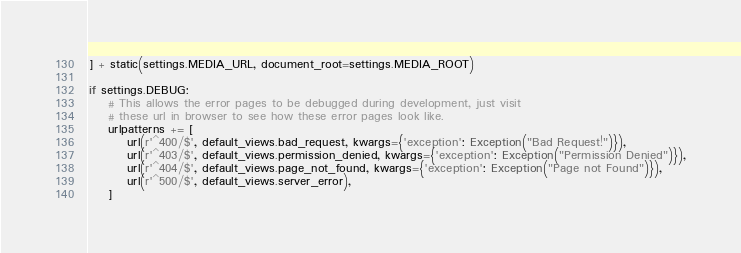<code> <loc_0><loc_0><loc_500><loc_500><_Python_>

] + static(settings.MEDIA_URL, document_root=settings.MEDIA_ROOT)

if settings.DEBUG:
    # This allows the error pages to be debugged during development, just visit
    # these url in browser to see how these error pages look like.
    urlpatterns += [
        url(r'^400/$', default_views.bad_request, kwargs={'exception': Exception("Bad Request!")}),
        url(r'^403/$', default_views.permission_denied, kwargs={'exception': Exception("Permission Denied")}),
        url(r'^404/$', default_views.page_not_found, kwargs={'exception': Exception("Page not Found")}),
        url(r'^500/$', default_views.server_error),
    ]
</code> 